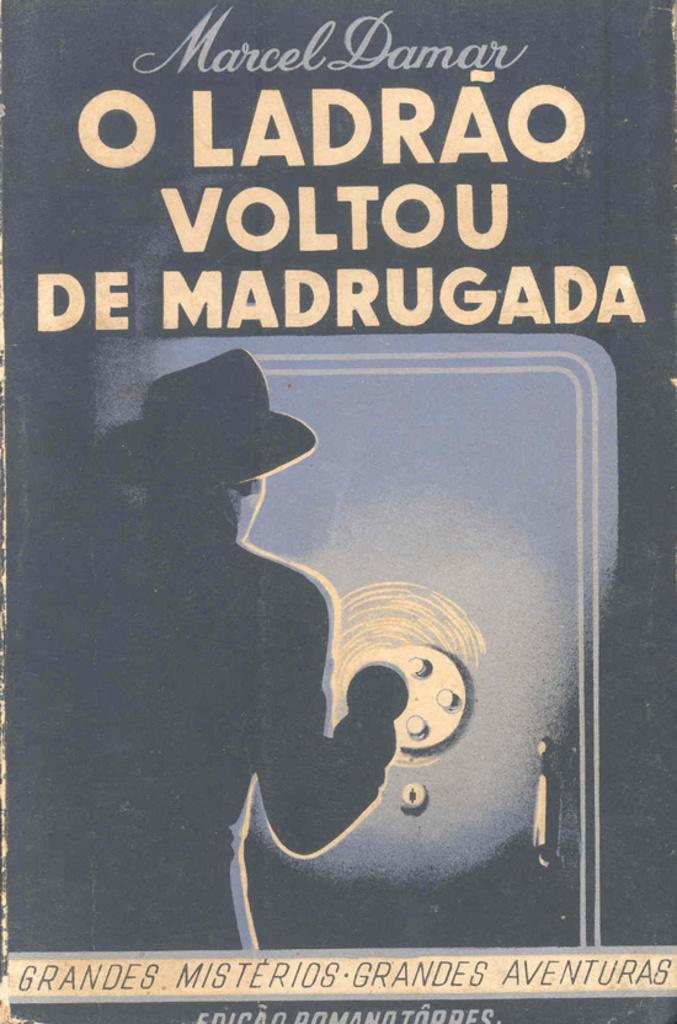What is the main subject of the image? The image contains a cover page of a book. Can you describe the person on the cover page? The person is wearing a hat and standing near a door on the cover page. What else can be seen on the cover page? There are words on the cover page. How does the person on the cover page increase the harmony of the room? There is no indication in the image that the person is increasing the harmony of the room, as the image only shows a cover page of a book. 